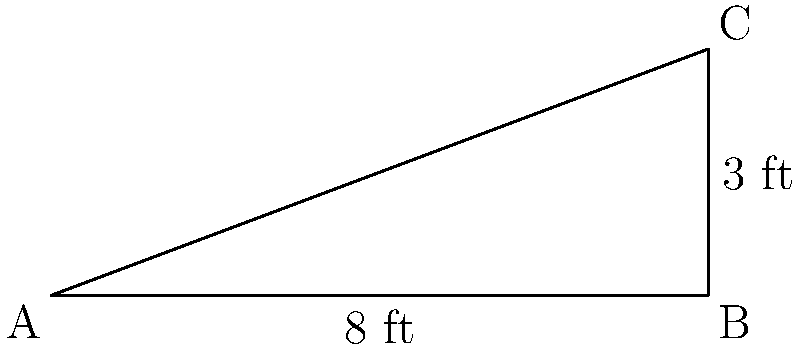You're planning to build a new garden shed with a sloped roof to store your gardening tools. The base of the shed is 8 feet wide, and the roof rises 3 feet at its peak. What is the angle of the roof slope in degrees? To find the angle of the roof slope, we can use trigonometry. Let's approach this step-by-step:

1. The diagram forms a right triangle, where:
   - The base (horizontal distance) is 8 feet
   - The height (vertical rise) is 3 feet
   - The angle we're looking for is the one between the base and the slope

2. We can use the arctangent (tan^(-1)) function to find this angle.

3. The tangent of an angle is the ratio of the opposite side to the adjacent side.
   In this case: $\tan(\theta) = \frac{\text{opposite}}{\text{adjacent}} = \frac{3}{8}$

4. To find the angle, we take the arctangent of this ratio:
   $\theta = \tan^{-1}(\frac{3}{8})$

5. Using a calculator or mathematical software:
   $\theta \approx 20.56°$

6. Rounding to the nearest degree:
   $\theta \approx 21°$

Therefore, the angle of the roof slope is approximately 21 degrees.
Answer: 21° 